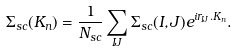Convert formula to latex. <formula><loc_0><loc_0><loc_500><loc_500>\Sigma _ { s c } ( { K } _ { n } ) = \frac { 1 } { N _ { s c } } \sum _ { I J } \Sigma _ { s c } ( I , J ) e ^ { i { r } _ { I J } . { K } _ { n } } .</formula> 